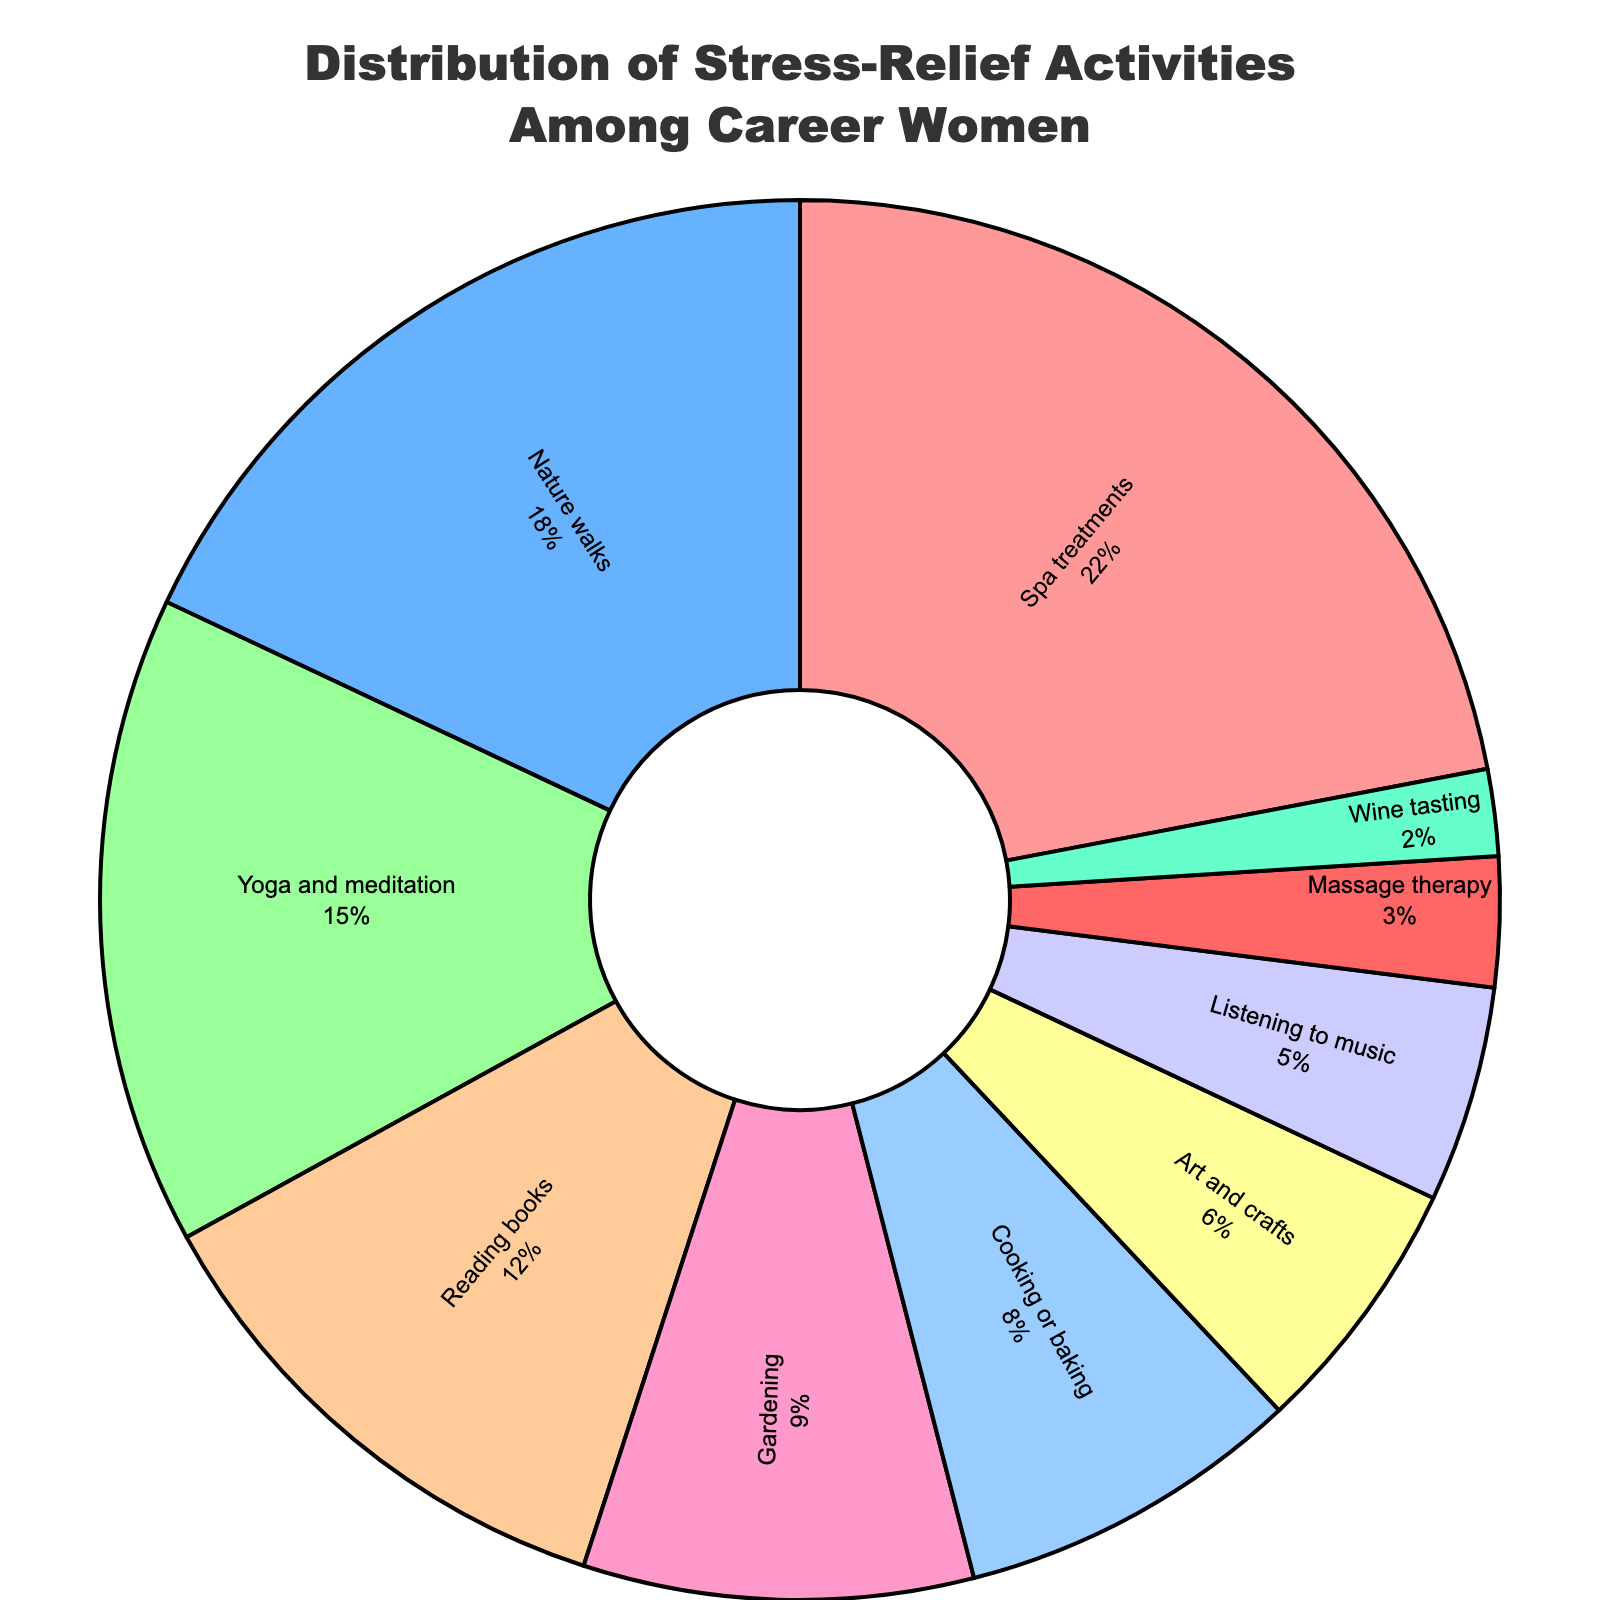Which activity has the highest percentage of participation? According to the pie chart, the activity with the largest segment (most significant part) represents the highest percentage of participation.
Answer: Spa treatments What is the combined percentage of Yoga and meditation, and Reading books? Add the percentages of Yoga and meditation (15%) and Reading books (12%) together. 15 + 12 = 27
Answer: 27 Which activity has a higher percentage: Cooking or baking, or Gardening? Compare the pie segments labeled Cooking or baking (8%) and Gardening (9%). 9% is greater than 8%.
Answer: Gardening Are there any activities with a percentage lower than 5%, and if so, which ones? Identify segments from the pie chart with a percentage value of less than 5%, finding those that meet this criterion.
Answer: Massage therapy, Wine tasting Which two activities combined make up exactly 20% of the participation? Identify segments in the pie chart whose percentages sum to 20%: Nature walks (18%) and Wine tasting (2%). 18 + 2 = 20.
Answer: Nature walks and Wine tasting What is the difference in percentage between Nature walks and Listening to music? Subtract the percentage of Listening to music (5%) from Nature walks (18%). 18 - 5 = 13
Answer: 13 If you combine the participation percentages of Massage therapy and Wine tasting, is it more or less than Yoga and meditation? Add the percentages of Massage therapy (3%) and Wine tasting (2%). Compare the sum (5%) with Yoga and meditation's percentage (15%). 5% is less than 15%.
Answer: Less What percentage of career women participate in Spa treatments compared to Art and crafts? Compare the percentages for Spa treatments (22%) and Art and crafts (6%). Spa treatments has a higher percentage.
Answer: Spa treatments What fraction of the pie chart does Cooking or baking represent in relation to Spa treatments? Calculate the fraction by dividing Cooking or baking's percentage (8%) by Spa treatments' percentage (22%). 8/22 = 0.36
Answer: 0.36 Which color represents the segment with the lowest percentage, and what activity does it correspond to? Identify the segment with the smallest slice (Wine tasting, 2%) and note its color (assuming blue based on the given color array).
Answer: Blue, Wine tasting 